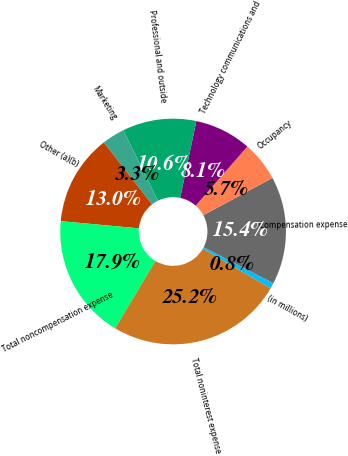<chart> <loc_0><loc_0><loc_500><loc_500><pie_chart><fcel>(in millions)<fcel>Compensation expense<fcel>Occupancy<fcel>Technology communications and<fcel>Professional and outside<fcel>Marketing<fcel>Other (a)(b)<fcel>Total noncompensation expense<fcel>Total noninterest expense<nl><fcel>0.83%<fcel>15.44%<fcel>5.7%<fcel>8.13%<fcel>10.57%<fcel>3.26%<fcel>13.01%<fcel>17.88%<fcel>25.18%<nl></chart> 